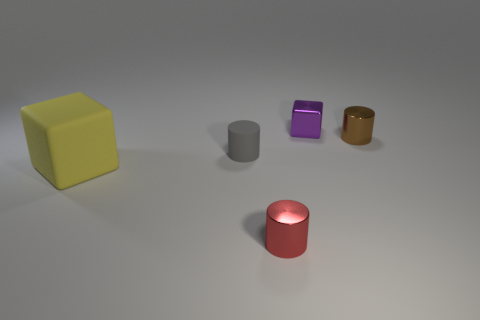Add 3 tiny purple cylinders. How many objects exist? 8 Subtract all blocks. How many objects are left? 3 Subtract 0 cyan spheres. How many objects are left? 5 Subtract all small green metal cubes. Subtract all red metal cylinders. How many objects are left? 4 Add 4 gray rubber cylinders. How many gray rubber cylinders are left? 5 Add 5 green things. How many green things exist? 5 